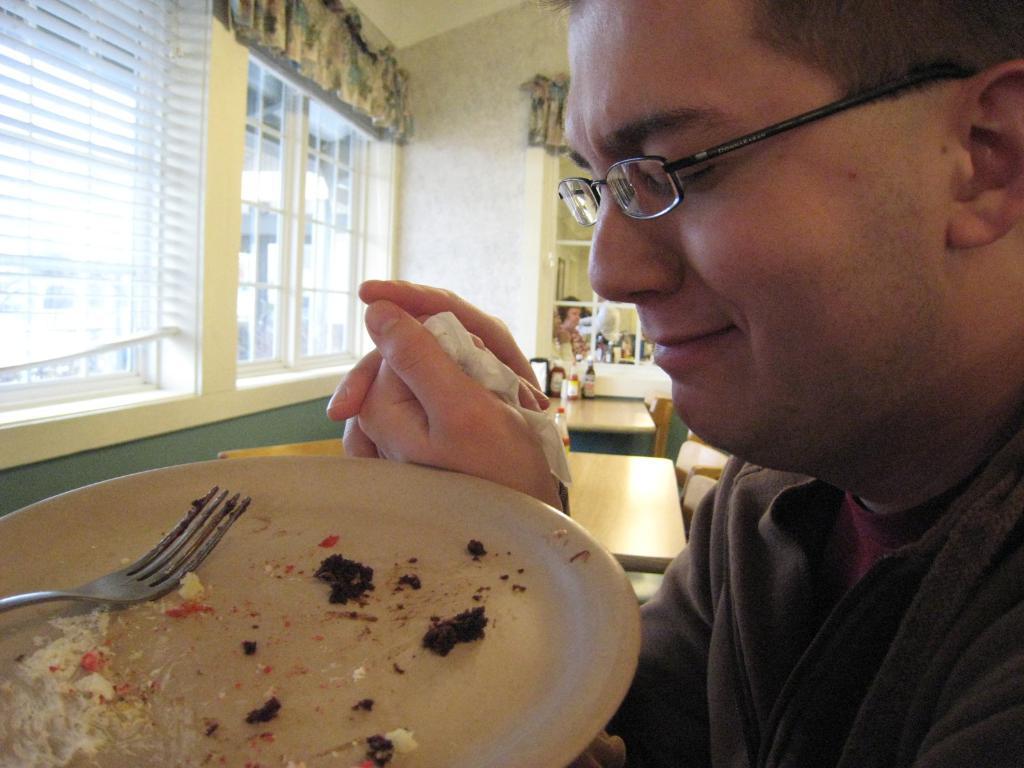Could you give a brief overview of what you see in this image? In this picture we can see few people, on the right side of the image we can see a man, he wore spectacles, in front of him we can see a plate and a fork, in the background we can see few bottles on the tables. 